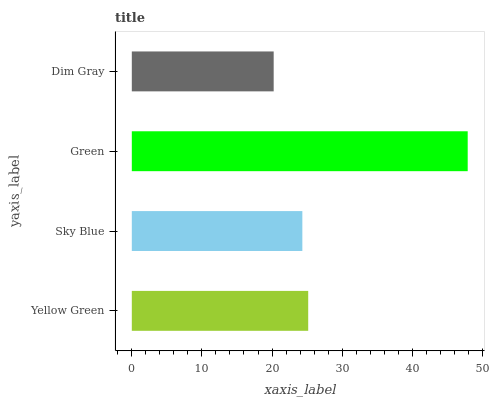Is Dim Gray the minimum?
Answer yes or no. Yes. Is Green the maximum?
Answer yes or no. Yes. Is Sky Blue the minimum?
Answer yes or no. No. Is Sky Blue the maximum?
Answer yes or no. No. Is Yellow Green greater than Sky Blue?
Answer yes or no. Yes. Is Sky Blue less than Yellow Green?
Answer yes or no. Yes. Is Sky Blue greater than Yellow Green?
Answer yes or no. No. Is Yellow Green less than Sky Blue?
Answer yes or no. No. Is Yellow Green the high median?
Answer yes or no. Yes. Is Sky Blue the low median?
Answer yes or no. Yes. Is Dim Gray the high median?
Answer yes or no. No. Is Green the low median?
Answer yes or no. No. 